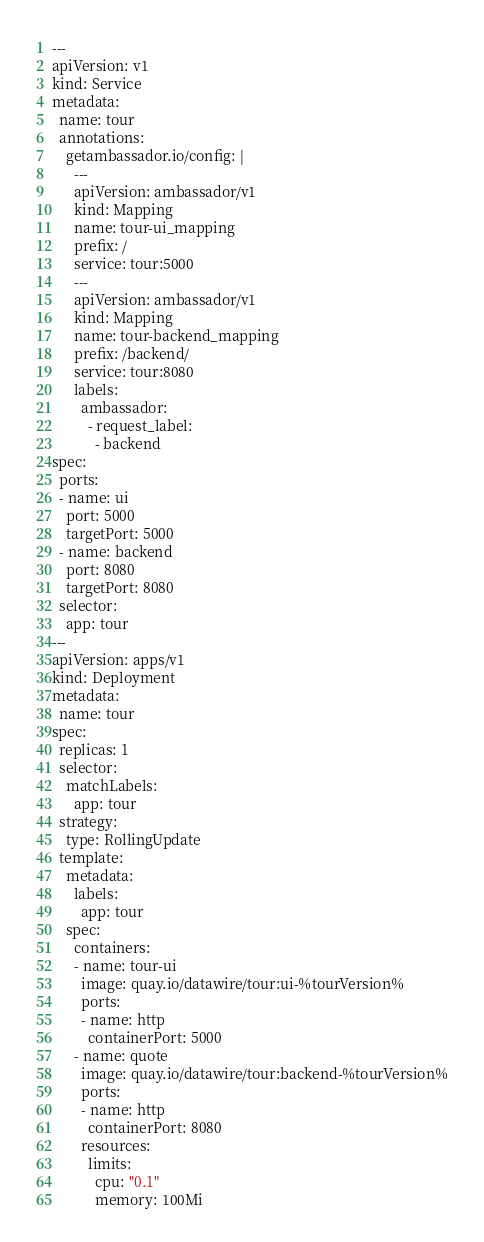Convert code to text. <code><loc_0><loc_0><loc_500><loc_500><_YAML_>---
apiVersion: v1
kind: Service
metadata:
  name: tour
  annotations:
    getambassador.io/config: |
      ---
      apiVersion: ambassador/v1
      kind: Mapping
      name: tour-ui_mapping
      prefix: /
      service: tour:5000
      ---
      apiVersion: ambassador/v1
      kind: Mapping
      name: tour-backend_mapping
      prefix: /backend/
      service: tour:8080
      labels:
        ambassador:
          - request_label:
            - backend
spec:
  ports:
  - name: ui
    port: 5000
    targetPort: 5000
  - name: backend
    port: 8080
    targetPort: 8080
  selector:
    app: tour
---
apiVersion: apps/v1
kind: Deployment
metadata:
  name: tour
spec:
  replicas: 1
  selector:
    matchLabels:
      app: tour
  strategy:
    type: RollingUpdate
  template:
    metadata:
      labels:
        app: tour
    spec:
      containers:
      - name: tour-ui
        image: quay.io/datawire/tour:ui-%tourVersion%
        ports:
        - name: http
          containerPort: 5000
      - name: quote
        image: quay.io/datawire/tour:backend-%tourVersion%
        ports:
        - name: http
          containerPort: 8080
        resources:
          limits:
            cpu: "0.1"
            memory: 100Mi
</code> 